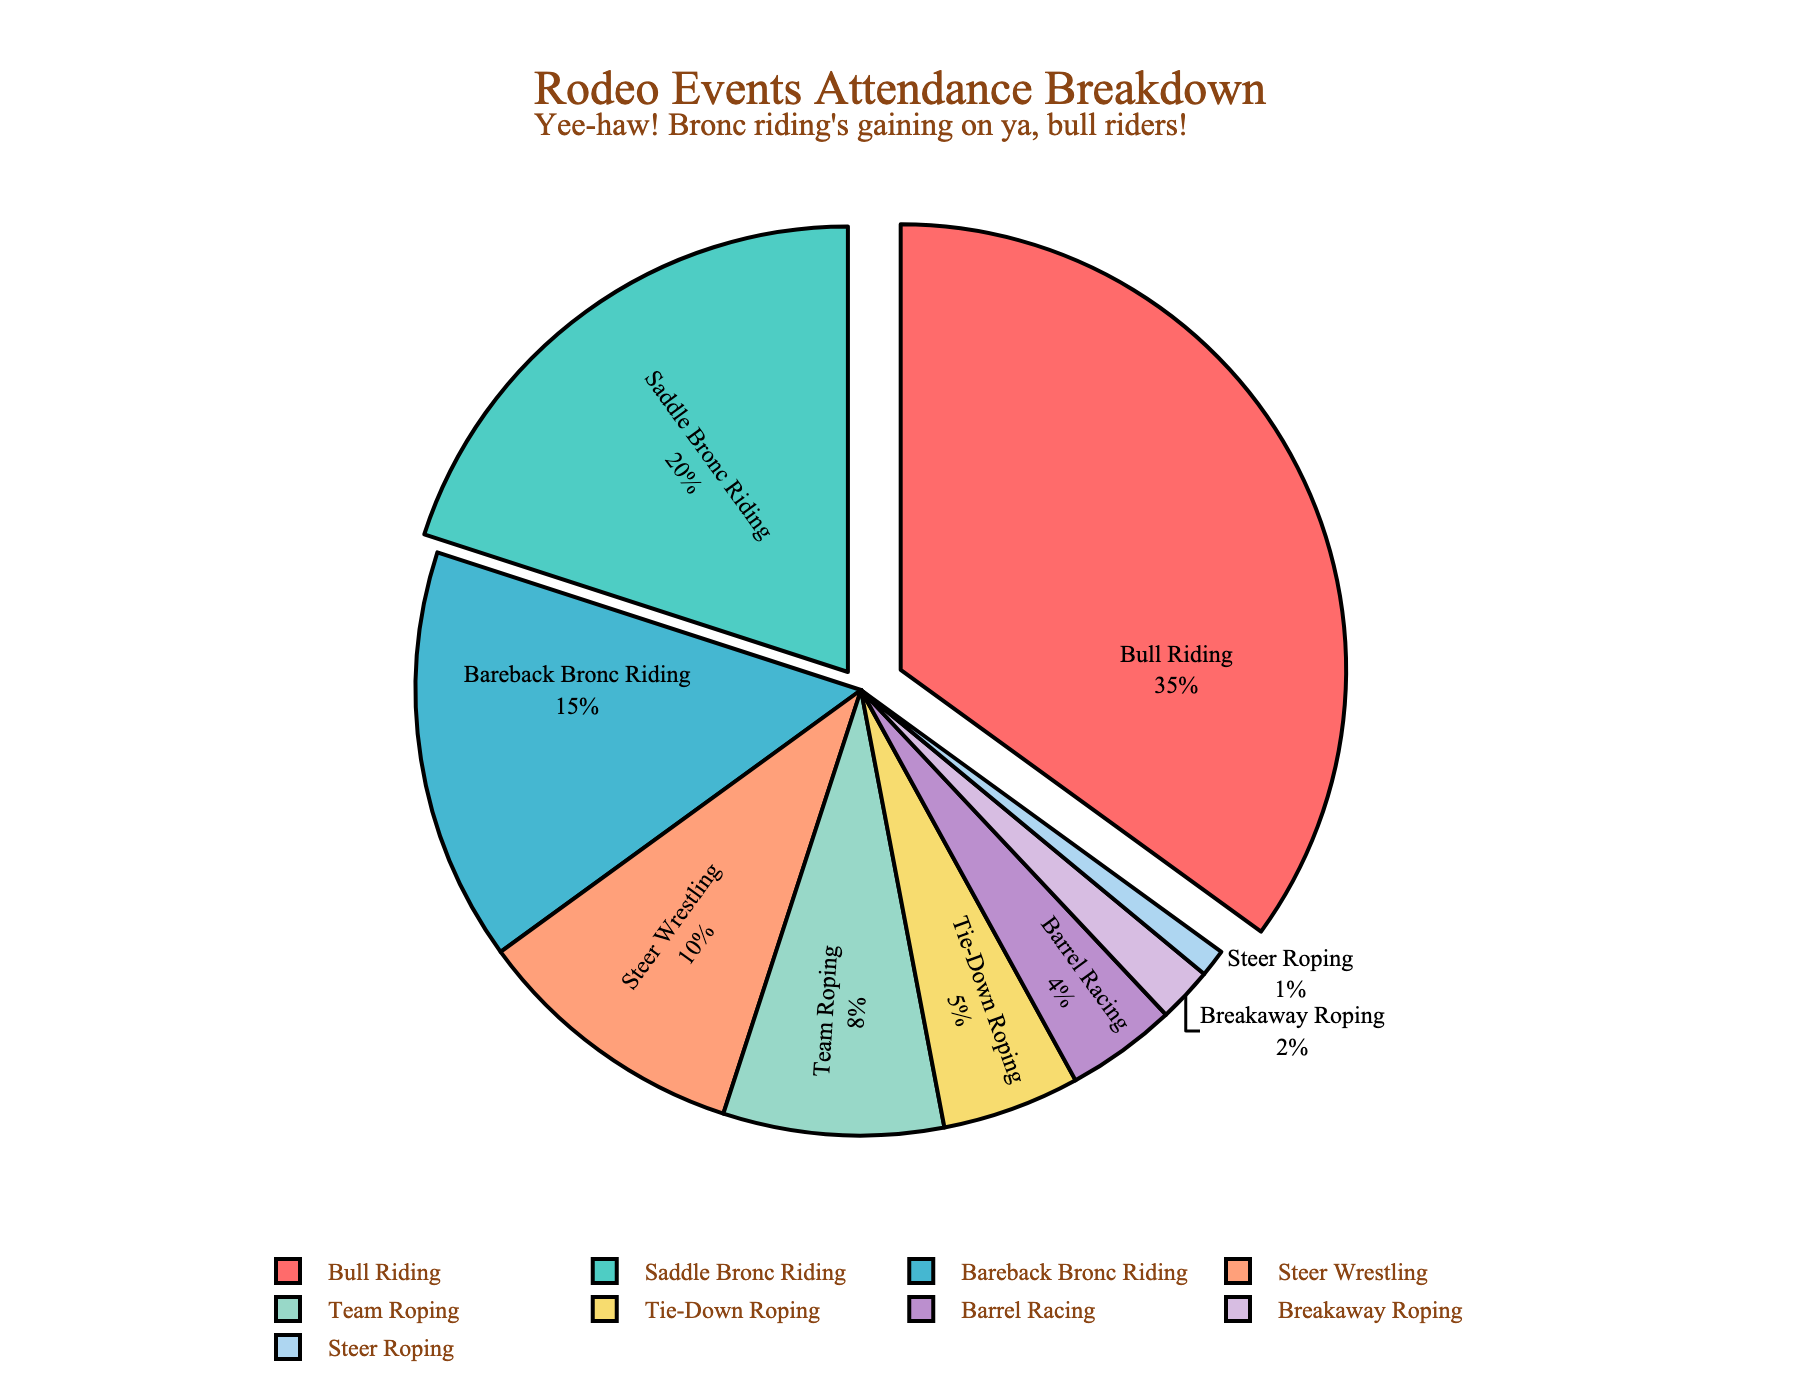Which event has the highest attendance percentage? The slice labeled "Bull Riding" shows 35%, which is the highest among all slices.
Answer: Bull Riding Which events combined have a higher attendance percentage than Bull Riding alone? Summing the attendance percentages of Saddle Bronc Riding (20%), Bareback Bronc Riding (15%), and Steer Wrestling (10%) results in 45%, which is higher than Bull Riding's 35%.
Answer: Saddle Bronc Riding, Bareback Bronc Riding, Steer Wrestling What is the total percentage for the roping events (Team Roping, Tie-Down Roping, Breakaway Roping, and Steer Roping)? Adding the percentages for Team Roping (8%), Tie-Down Roping (5%), Breakaway Roping (2%), and Steer Roping (1%) results in a total of 16%.
Answer: 16% Which event has the smallest slice in the pie chart? The slice labeled "Steer Roping" shows 1%, which is the smallest among all slices.
Answer: Steer Roping What is the difference in attendance percentage between Saddle Bronc Riding and Bareback Bronc Riding? Saddle Bronc Riding has 20% and Bareback Bronc Riding has 15%. The difference is 20% - 15% = 5%.
Answer: 5% Which event has an attendance percentage closest to Barrel Racing? Tie-Down Roping has an attendance of 5%, which is closest to Barrel Racing's 4%.
Answer: Tie-Down Roping Is team roping attendance greater than breakaway roping attendance or less than steer wrestling attendance? Team Roping has an attendance of 8%, which is greater than Breakaway Roping's 2% but less than Steer Wrestling's 10%.
Answer: Greater than Breakaway Roping, Less than Steer Wrestling What is the combined attendance percentage of the events with the top three highest attendances? Summing the percentages of Bull Riding (35%), Saddle Bronc Riding (20%), and Bareback Bronc Riding (15%) results in 70%.
Answer: 70% What portion of the pie chart does barrel racing represent in terms of color? The slice representing Barrel Racing is colored in light purple among various other colors used in the pie chart.
Answer: Light Purple 